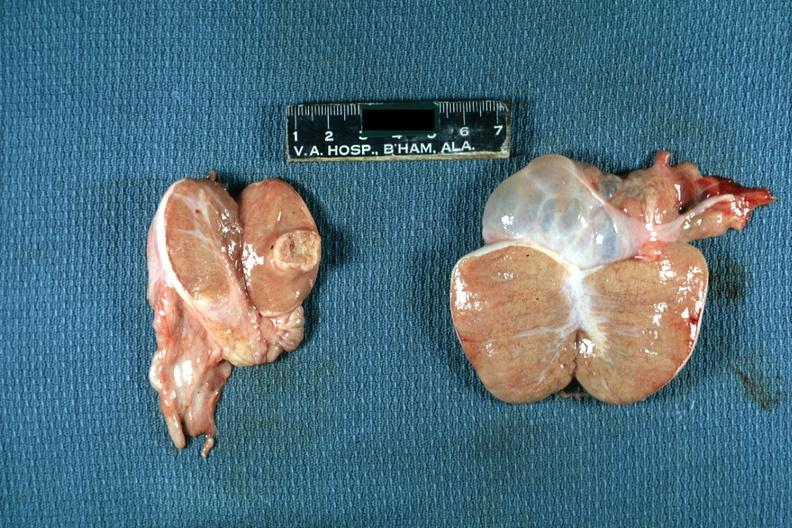s interstitial cell tumor present?
Answer the question using a single word or phrase. Yes 